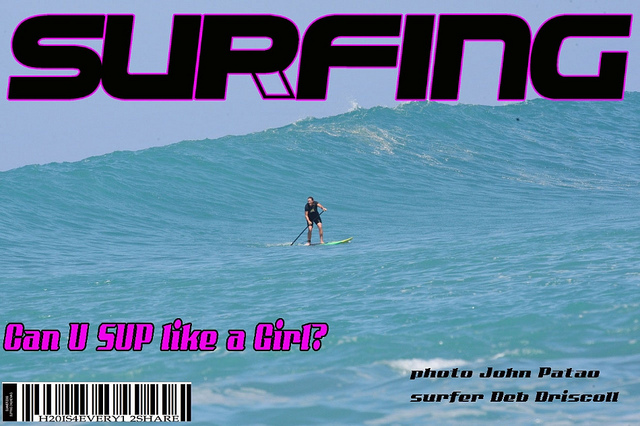Identify the text contained in this image. SURFING Can U SUP like surfer Deb Driscoll Patao john photo Girl? a 2SHARE H20IS4EVERY1 